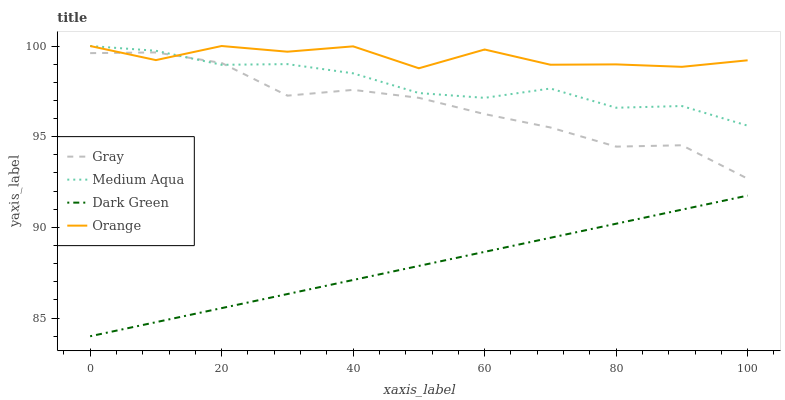Does Dark Green have the minimum area under the curve?
Answer yes or no. Yes. Does Orange have the maximum area under the curve?
Answer yes or no. Yes. Does Gray have the minimum area under the curve?
Answer yes or no. No. Does Gray have the maximum area under the curve?
Answer yes or no. No. Is Dark Green the smoothest?
Answer yes or no. Yes. Is Orange the roughest?
Answer yes or no. Yes. Is Gray the smoothest?
Answer yes or no. No. Is Gray the roughest?
Answer yes or no. No. Does Dark Green have the lowest value?
Answer yes or no. Yes. Does Gray have the lowest value?
Answer yes or no. No. Does Medium Aqua have the highest value?
Answer yes or no. Yes. Does Gray have the highest value?
Answer yes or no. No. Is Dark Green less than Gray?
Answer yes or no. Yes. Is Orange greater than Dark Green?
Answer yes or no. Yes. Does Orange intersect Medium Aqua?
Answer yes or no. Yes. Is Orange less than Medium Aqua?
Answer yes or no. No. Is Orange greater than Medium Aqua?
Answer yes or no. No. Does Dark Green intersect Gray?
Answer yes or no. No. 